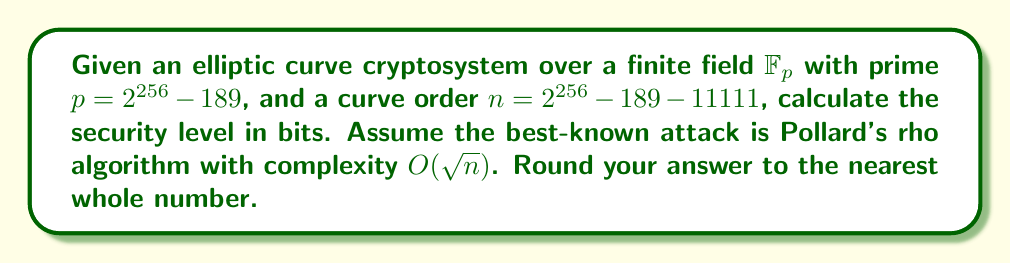Show me your answer to this math problem. To evaluate the security level of an elliptic curve cryptosystem, we need to follow these steps:

1. Identify the curve order $n$:
   $n = 2^{256} - 189 - 11111$

2. Determine the complexity of the best-known attack:
   The question states that Pollard's rho algorithm has complexity $O(\sqrt{n})$

3. Calculate $\sqrt{n}$:
   $$\sqrt{n} = \sqrt{2^{256} - 189 - 11111}$$

4. Simplify the expression under the square root:
   $$2^{256} - 189 - 11111 \approx 2^{256} - 11300$$
   This approximation is valid because 11300 is negligible compared to $2^{256}$

5. Calculate the logarithm base 2:
   $$\log_2(\sqrt{2^{256} - 11300}) \approx \log_2(\sqrt{2^{256}}) = \log_2(2^{128}) = 128$$

6. Round to the nearest whole number:
   128 (no rounding needed in this case)

The security level in bits is approximately 128, which means it would take roughly $2^{128}$ operations to break the cryptosystem using the best-known attack.
Answer: 128 bits 